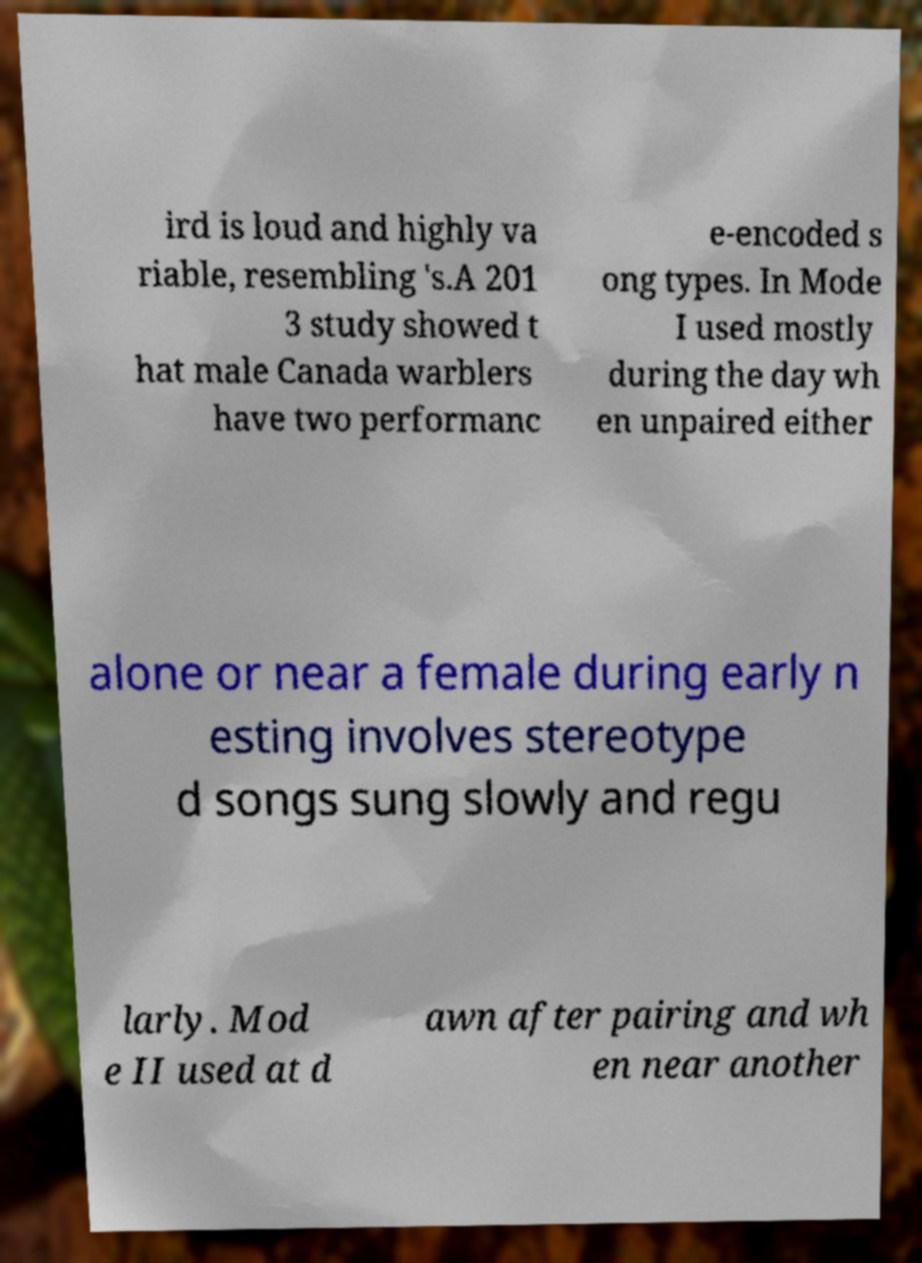For documentation purposes, I need the text within this image transcribed. Could you provide that? ird is loud and highly va riable, resembling 's.A 201 3 study showed t hat male Canada warblers have two performanc e-encoded s ong types. In Mode I used mostly during the day wh en unpaired either alone or near a female during early n esting involves stereotype d songs sung slowly and regu larly. Mod e II used at d awn after pairing and wh en near another 